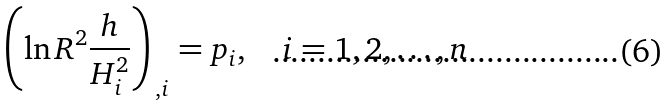<formula> <loc_0><loc_0><loc_500><loc_500>\left ( \ln R ^ { 2 } \frac { h } { H _ { i } ^ { 2 } } \right ) _ { \, , i } = p _ { i } , \quad i = 1 , 2 , \dots , n</formula> 